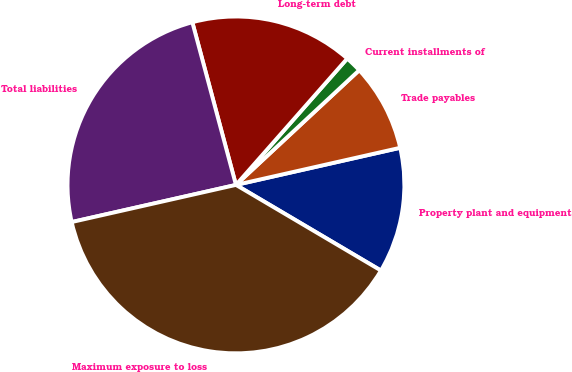Convert chart to OTSL. <chart><loc_0><loc_0><loc_500><loc_500><pie_chart><fcel>Property plant and equipment<fcel>Trade payables<fcel>Current installments of<fcel>Long-term debt<fcel>Total liabilities<fcel>Maximum exposure to loss<nl><fcel>12.03%<fcel>8.39%<fcel>1.58%<fcel>15.66%<fcel>24.37%<fcel>37.97%<nl></chart> 